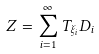Convert formula to latex. <formula><loc_0><loc_0><loc_500><loc_500>Z = \sum _ { i = 1 } ^ { \infty } T _ { \xi _ { i } } D _ { i }</formula> 